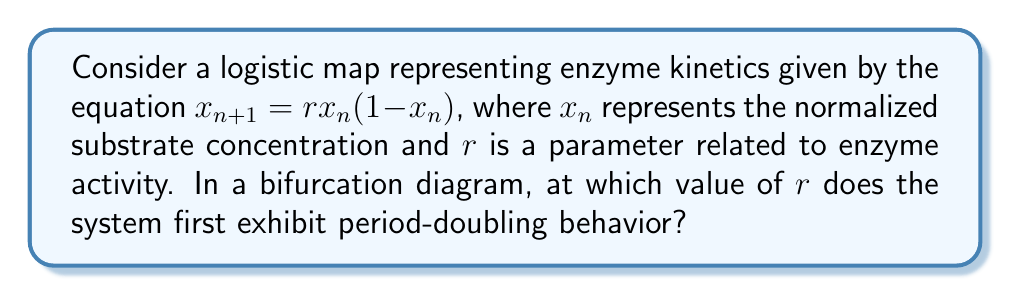Help me with this question. To analyze the bifurcation diagram of this logistic map:

1) The logistic map is given by $x_{n+1} = rx_n(1-x_n)$, where $x_n \in [0,1]$ and $r > 0$.

2) For $0 < r \leq 1$, the system has a single fixed point at $x = 0$.

3) For $1 < r < 3$, there's a single non-zero fixed point at $x = 1 - \frac{1}{r}$.

4) The stability of this fixed point changes at $r = 3$. To see this, we calculate the derivative:

   $$\frac{d}{dx}(rx(1-x)) = r(1-2x)$$

5) At the fixed point $x = 1 - \frac{1}{r}$, the derivative is:

   $$r(1-2(1-\frac{1}{r})) = r(2\frac{1}{r}-1) = 2-r$$

6) The fixed point is stable when $|-2+r| < 1$, which gives us $1 < r < 3$.

7) At $r = 3$, the system undergoes its first period-doubling bifurcation. This means the system oscillates between two values instead of converging to a single fixed point.

8) For $3 < r < 1+\sqrt{6} \approx 3.45$, the system oscillates between two values.

9) Further period-doubling bifurcations occur as $r$ increases, eventually leading to chaos.

Therefore, the first period-doubling behavior occurs at $r = 3$.
Answer: $r = 3$ 